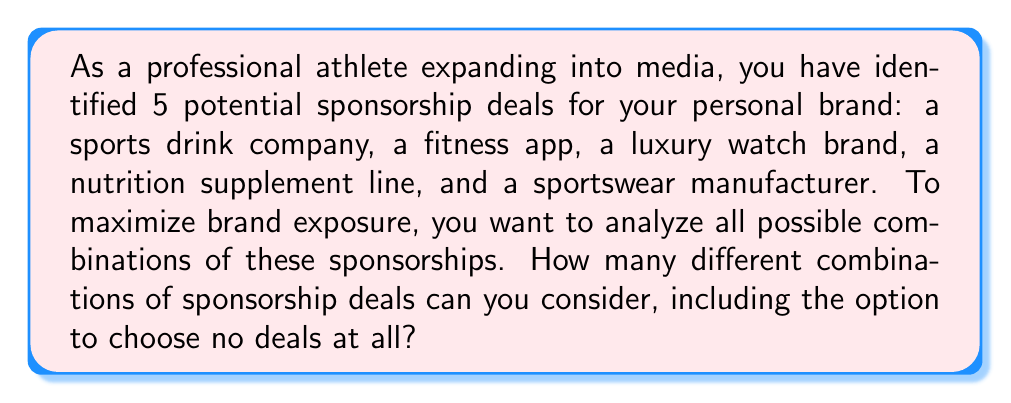Give your solution to this math problem. To solve this problem, we need to use the concept of power sets from set theory. The power set of a set S is the set of all subsets of S, including the empty set and S itself.

Let's approach this step-by-step:

1) First, let's define our set of potential sponsorship deals:
   $S = \{$sports drink, fitness app, luxury watch, nutrition supplement, sportswear$\}$

2) The number of elements in set S is 5.

3) For a set with n elements, the number of elements in its power set is given by the formula:
   $2^n$

4) This is because for each element, we have two choices: include it in a subset or not. And we make this choice independently for each element.

5) In our case, $n = 5$, so the number of elements in the power set is:
   $2^5 = 32$

6) We can verify this by listing out all possibilities:
   - 1 way to choose no deals (empty set)
   - 5 ways to choose 1 deal ($\binom{5}{1} = 5$)
   - 10 ways to choose 2 deals ($\binom{5}{2} = 10$)
   - 10 ways to choose 3 deals ($\binom{5}{3} = 10$)
   - 5 ways to choose 4 deals ($\binom{5}{4} = 5$)
   - 1 way to choose all 5 deals

   Total: $1 + 5 + 10 + 10 + 5 + 1 = 32$

Therefore, there are 32 different combinations of sponsorship deals to consider, including the option to choose no deals at all.
Answer: $32$ combinations 